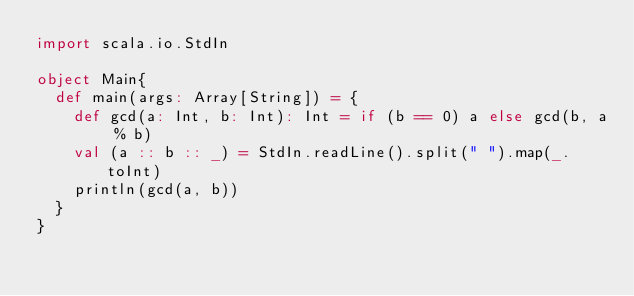<code> <loc_0><loc_0><loc_500><loc_500><_Scala_>import scala.io.StdIn
 
object Main{
  def main(args: Array[String]) = {
    def gcd(a: Int, b: Int): Int = if (b == 0) a else gcd(b, a % b)
    val (a :: b :: _) = StdIn.readLine().split(" ").map(_.toInt)
    println(gcd(a, b))
  }
}
 </code> 